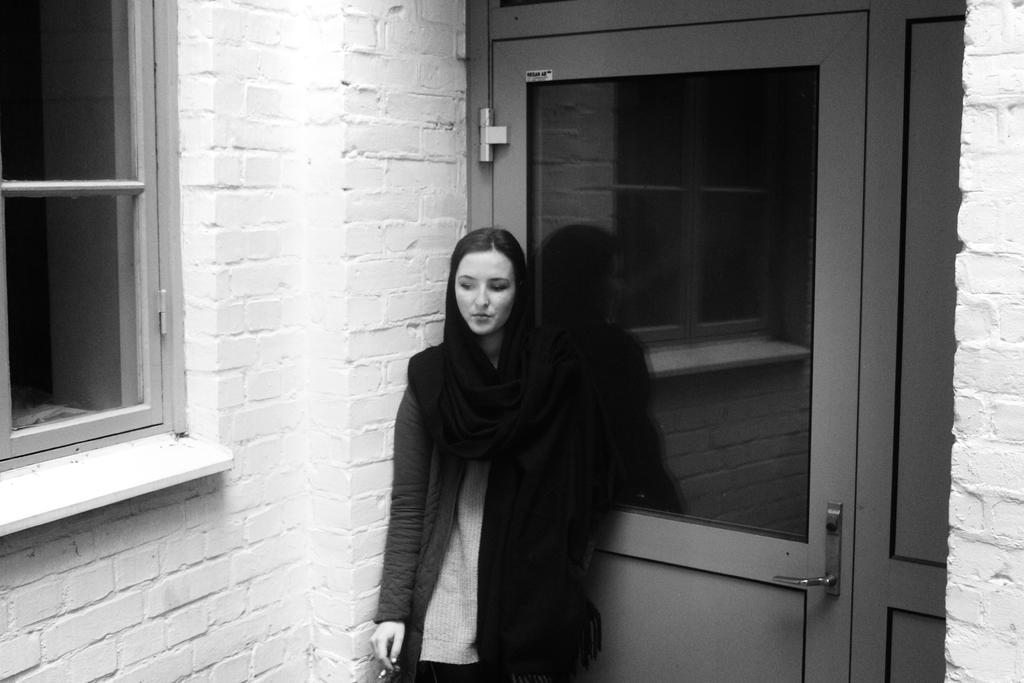Who is present in the image? There is a woman in the image. What can be seen in the background of the image? There is a door, a window, and a wall in the background of the image. What type of mint is growing on the woman's tongue in the image? There is no mention of mint or a tongue in the image, so this detail cannot be confirmed. 